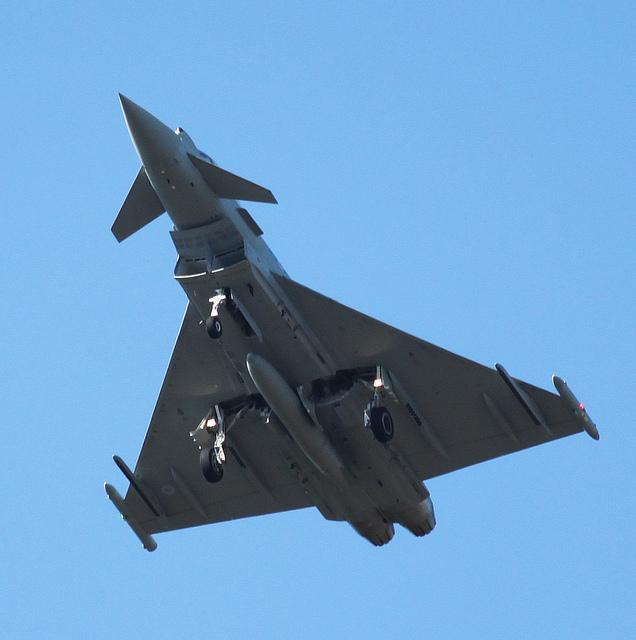Is this a war plane?
Keep it brief. Yes. Is the plane in the sky?
Be succinct. Yes. Is this a triangular plane?
Keep it brief. Yes. Is it sunny?
Give a very brief answer. Yes. 